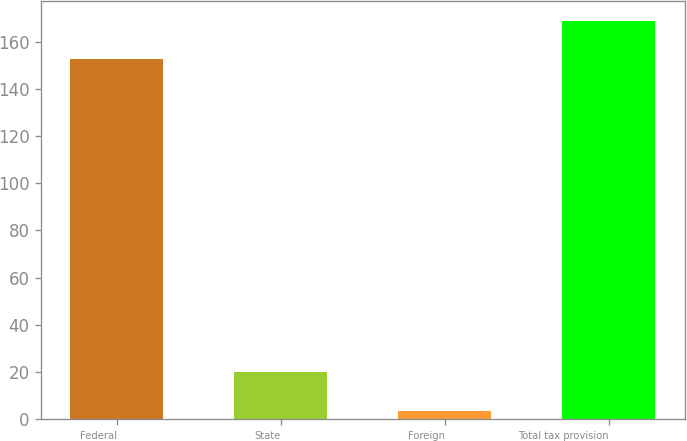Convert chart. <chart><loc_0><loc_0><loc_500><loc_500><bar_chart><fcel>Federal<fcel>State<fcel>Foreign<fcel>Total tax provision<nl><fcel>152.5<fcel>19.91<fcel>3.5<fcel>168.91<nl></chart> 